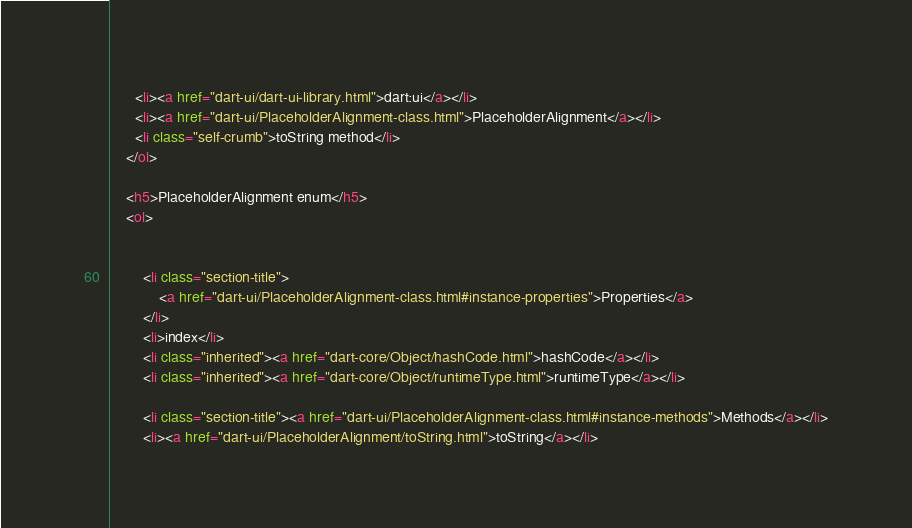<code> <loc_0><loc_0><loc_500><loc_500><_HTML_>      <li><a href="dart-ui/dart-ui-library.html">dart:ui</a></li>
      <li><a href="dart-ui/PlaceholderAlignment-class.html">PlaceholderAlignment</a></li>
      <li class="self-crumb">toString method</li>
    </ol>
    
    <h5>PlaceholderAlignment enum</h5>
    <ol>
    
    
        <li class="section-title">
            <a href="dart-ui/PlaceholderAlignment-class.html#instance-properties">Properties</a>
        </li>
        <li>index</li>
        <li class="inherited"><a href="dart-core/Object/hashCode.html">hashCode</a></li>
        <li class="inherited"><a href="dart-core/Object/runtimeType.html">runtimeType</a></li>
    
        <li class="section-title"><a href="dart-ui/PlaceholderAlignment-class.html#instance-methods">Methods</a></li>
        <li><a href="dart-ui/PlaceholderAlignment/toString.html">toString</a></li></code> 